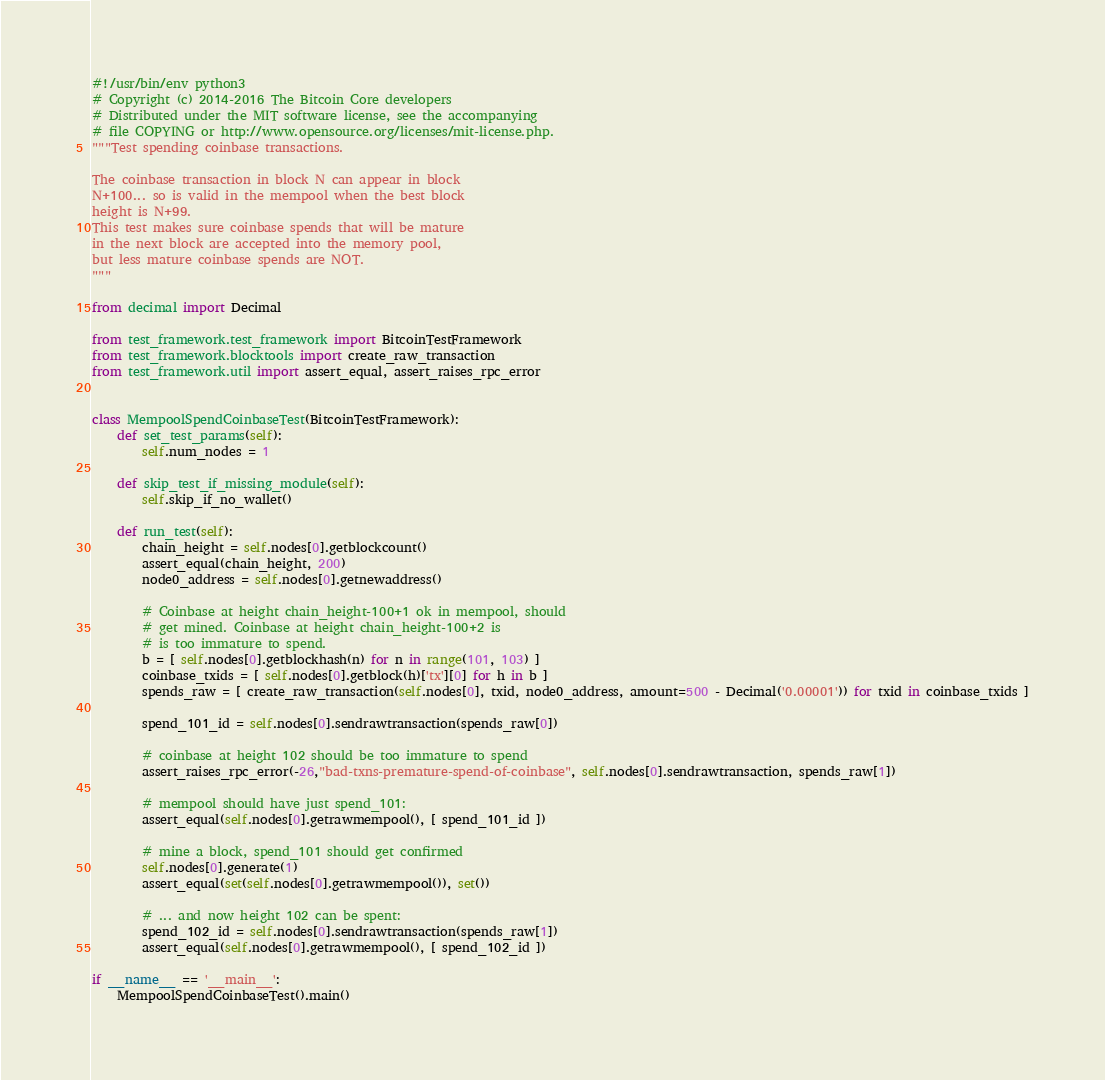Convert code to text. <code><loc_0><loc_0><loc_500><loc_500><_Python_>#!/usr/bin/env python3
# Copyright (c) 2014-2016 The Bitcoin Core developers
# Distributed under the MIT software license, see the accompanying
# file COPYING or http://www.opensource.org/licenses/mit-license.php.
"""Test spending coinbase transactions.

The coinbase transaction in block N can appear in block
N+100... so is valid in the mempool when the best block
height is N+99.
This test makes sure coinbase spends that will be mature
in the next block are accepted into the memory pool,
but less mature coinbase spends are NOT.
"""

from decimal import Decimal

from test_framework.test_framework import BitcoinTestFramework
from test_framework.blocktools import create_raw_transaction
from test_framework.util import assert_equal, assert_raises_rpc_error


class MempoolSpendCoinbaseTest(BitcoinTestFramework):
    def set_test_params(self):
        self.num_nodes = 1

    def skip_test_if_missing_module(self):
        self.skip_if_no_wallet()

    def run_test(self):
        chain_height = self.nodes[0].getblockcount()
        assert_equal(chain_height, 200)
        node0_address = self.nodes[0].getnewaddress()

        # Coinbase at height chain_height-100+1 ok in mempool, should
        # get mined. Coinbase at height chain_height-100+2 is
        # is too immature to spend.
        b = [ self.nodes[0].getblockhash(n) for n in range(101, 103) ]
        coinbase_txids = [ self.nodes[0].getblock(h)['tx'][0] for h in b ]
        spends_raw = [ create_raw_transaction(self.nodes[0], txid, node0_address, amount=500 - Decimal('0.00001')) for txid in coinbase_txids ]

        spend_101_id = self.nodes[0].sendrawtransaction(spends_raw[0])

        # coinbase at height 102 should be too immature to spend
        assert_raises_rpc_error(-26,"bad-txns-premature-spend-of-coinbase", self.nodes[0].sendrawtransaction, spends_raw[1])

        # mempool should have just spend_101:
        assert_equal(self.nodes[0].getrawmempool(), [ spend_101_id ])

        # mine a block, spend_101 should get confirmed
        self.nodes[0].generate(1)
        assert_equal(set(self.nodes[0].getrawmempool()), set())

        # ... and now height 102 can be spent:
        spend_102_id = self.nodes[0].sendrawtransaction(spends_raw[1])
        assert_equal(self.nodes[0].getrawmempool(), [ spend_102_id ])

if __name__ == '__main__':
    MempoolSpendCoinbaseTest().main()
</code> 